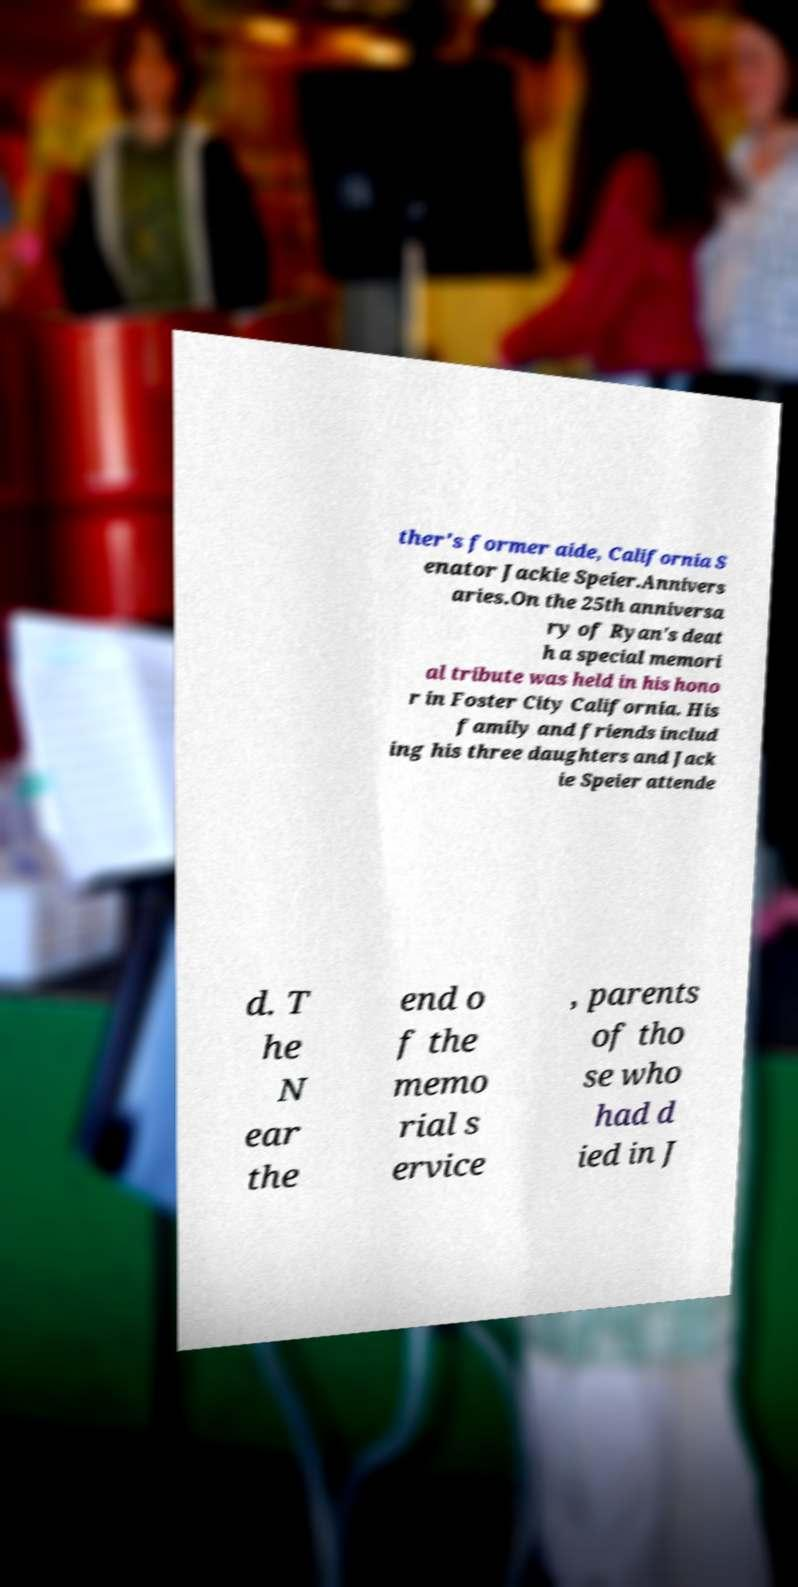I need the written content from this picture converted into text. Can you do that? ther's former aide, California S enator Jackie Speier.Annivers aries.On the 25th anniversa ry of Ryan's deat h a special memori al tribute was held in his hono r in Foster City California. His family and friends includ ing his three daughters and Jack ie Speier attende d. T he N ear the end o f the memo rial s ervice , parents of tho se who had d ied in J 